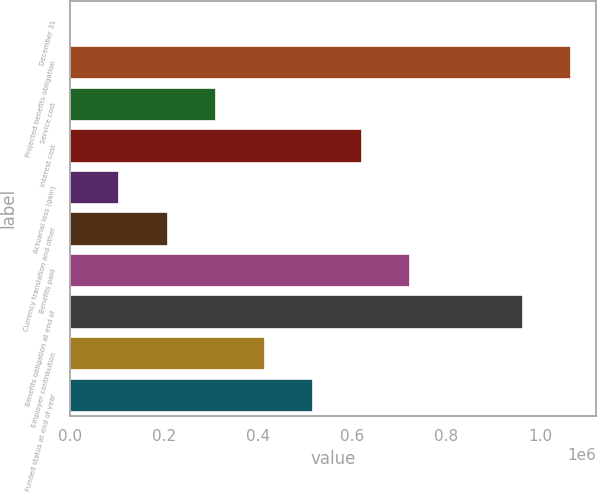<chart> <loc_0><loc_0><loc_500><loc_500><bar_chart><fcel>December 31<fcel>Projected benefits obligation<fcel>Service cost<fcel>Interest cost<fcel>Actuarial loss (gain)<fcel>Currency translation and other<fcel>Benefits paid<fcel>Benefits obligation at end of<fcel>Employer contribution<fcel>Funded status at end of year<nl><fcel>2008<fcel>1.06673e+06<fcel>311402<fcel>620796<fcel>105139<fcel>208271<fcel>723928<fcel>963597<fcel>414534<fcel>517665<nl></chart> 